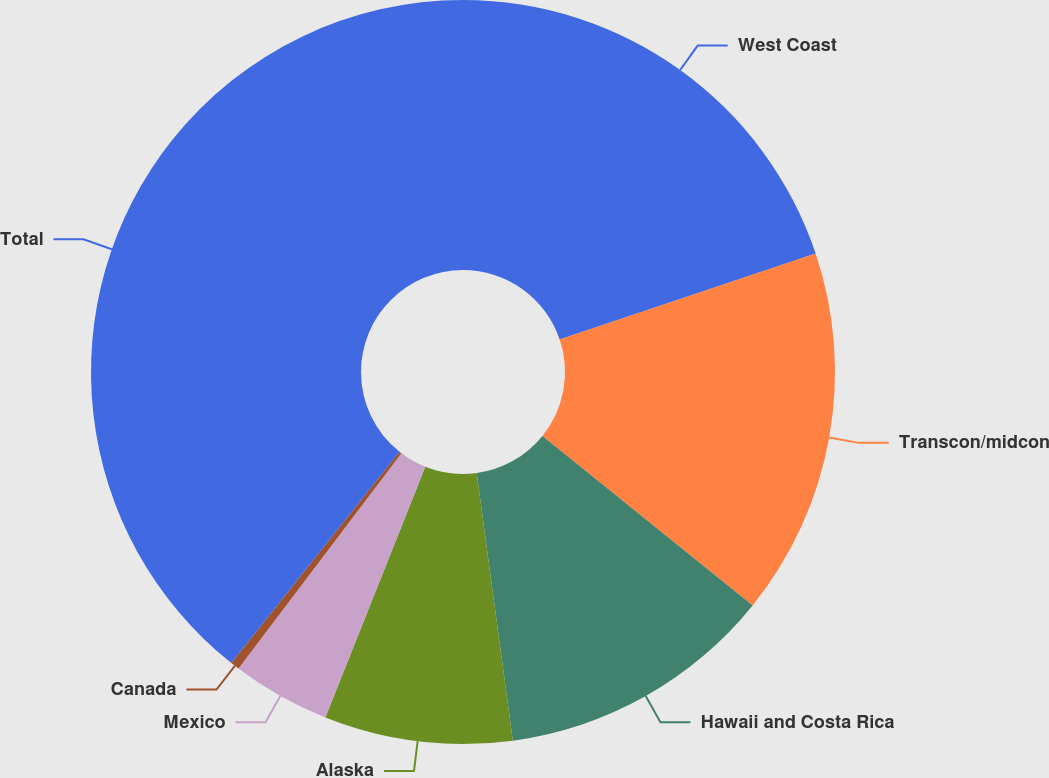<chart> <loc_0><loc_0><loc_500><loc_500><pie_chart><fcel>West Coast<fcel>Transcon/midcon<fcel>Hawaii and Costa Rica<fcel>Alaska<fcel>Mexico<fcel>Canada<fcel>Total<nl><fcel>19.84%<fcel>15.95%<fcel>12.06%<fcel>8.17%<fcel>4.28%<fcel>0.39%<fcel>39.29%<nl></chart> 